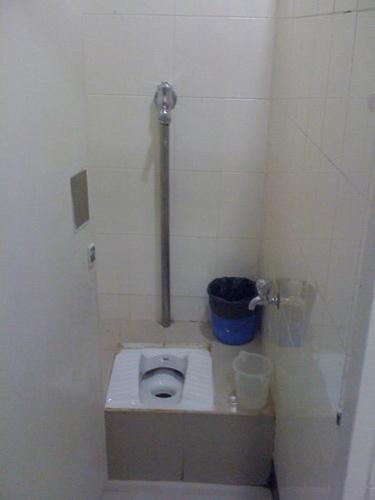What color is the trash can?
Give a very brief answer. Blue. What country is this likely to be located in?
Give a very brief answer. Europe. How many toilets are there?
Write a very short answer. 1. Is there a bag in the trash canister?
Give a very brief answer. Yes. What would come out of the metal pipe?
Be succinct. Water. Is this a normal place to see toilets?
Concise answer only. Yes. Is there a place for trash?
Answer briefly. Yes. 